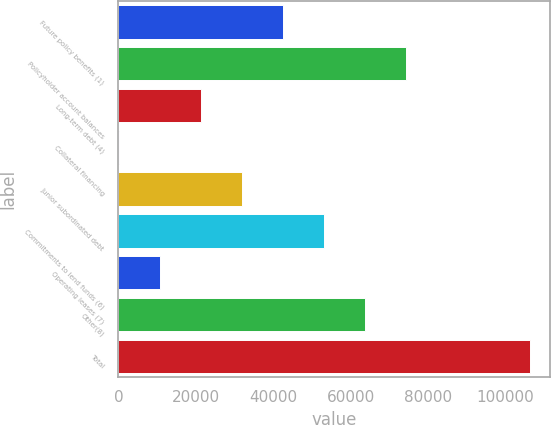Convert chart to OTSL. <chart><loc_0><loc_0><loc_500><loc_500><bar_chart><fcel>Future policy benefits (1)<fcel>Policyholder account balances<fcel>Long-term debt (4)<fcel>Collateral financing<fcel>Junior subordinated debt<fcel>Commitments to lend funds (6)<fcel>Operating leases (7)<fcel>Other(8)<fcel>Total<nl><fcel>42557.6<fcel>74384.3<fcel>21339.8<fcel>122<fcel>31948.7<fcel>53166.5<fcel>10730.9<fcel>63775.4<fcel>106211<nl></chart> 